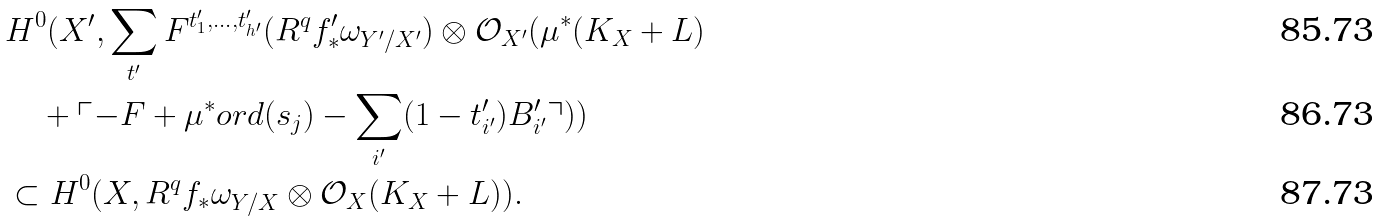Convert formula to latex. <formula><loc_0><loc_0><loc_500><loc_500>& H ^ { 0 } ( X ^ { \prime } , \sum _ { t ^ { \prime } } F ^ { t ^ { \prime } _ { 1 } , \dots , t ^ { \prime } _ { h ^ { \prime } } } ( R ^ { q } f ^ { \prime } _ { * } \omega _ { Y ^ { \prime } / X ^ { \prime } } ) \otimes \mathcal { O } _ { X ^ { \prime } } ( \mu ^ { * } ( K _ { X } + L ) \\ & \quad + \ulcorner - F + \mu ^ { * } o r d ( s _ { j } ) - \sum _ { i ^ { \prime } } ( 1 - t ^ { \prime } _ { i ^ { \prime } } ) B ^ { \prime } _ { i ^ { \prime } } \urcorner ) ) \\ & \subset H ^ { 0 } ( X , R ^ { q } f _ { * } \omega _ { Y / X } \otimes \mathcal { O } _ { X } ( K _ { X } + L ) ) .</formula> 